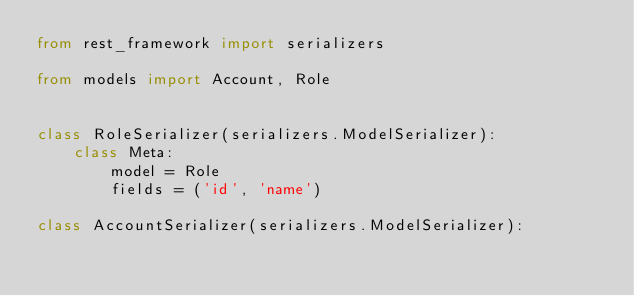<code> <loc_0><loc_0><loc_500><loc_500><_Python_>from rest_framework import serializers

from models import Account, Role


class RoleSerializer(serializers.ModelSerializer):
    class Meta:
        model = Role
        fields = ('id', 'name')
        
class AccountSerializer(serializers.ModelSerializer):</code> 